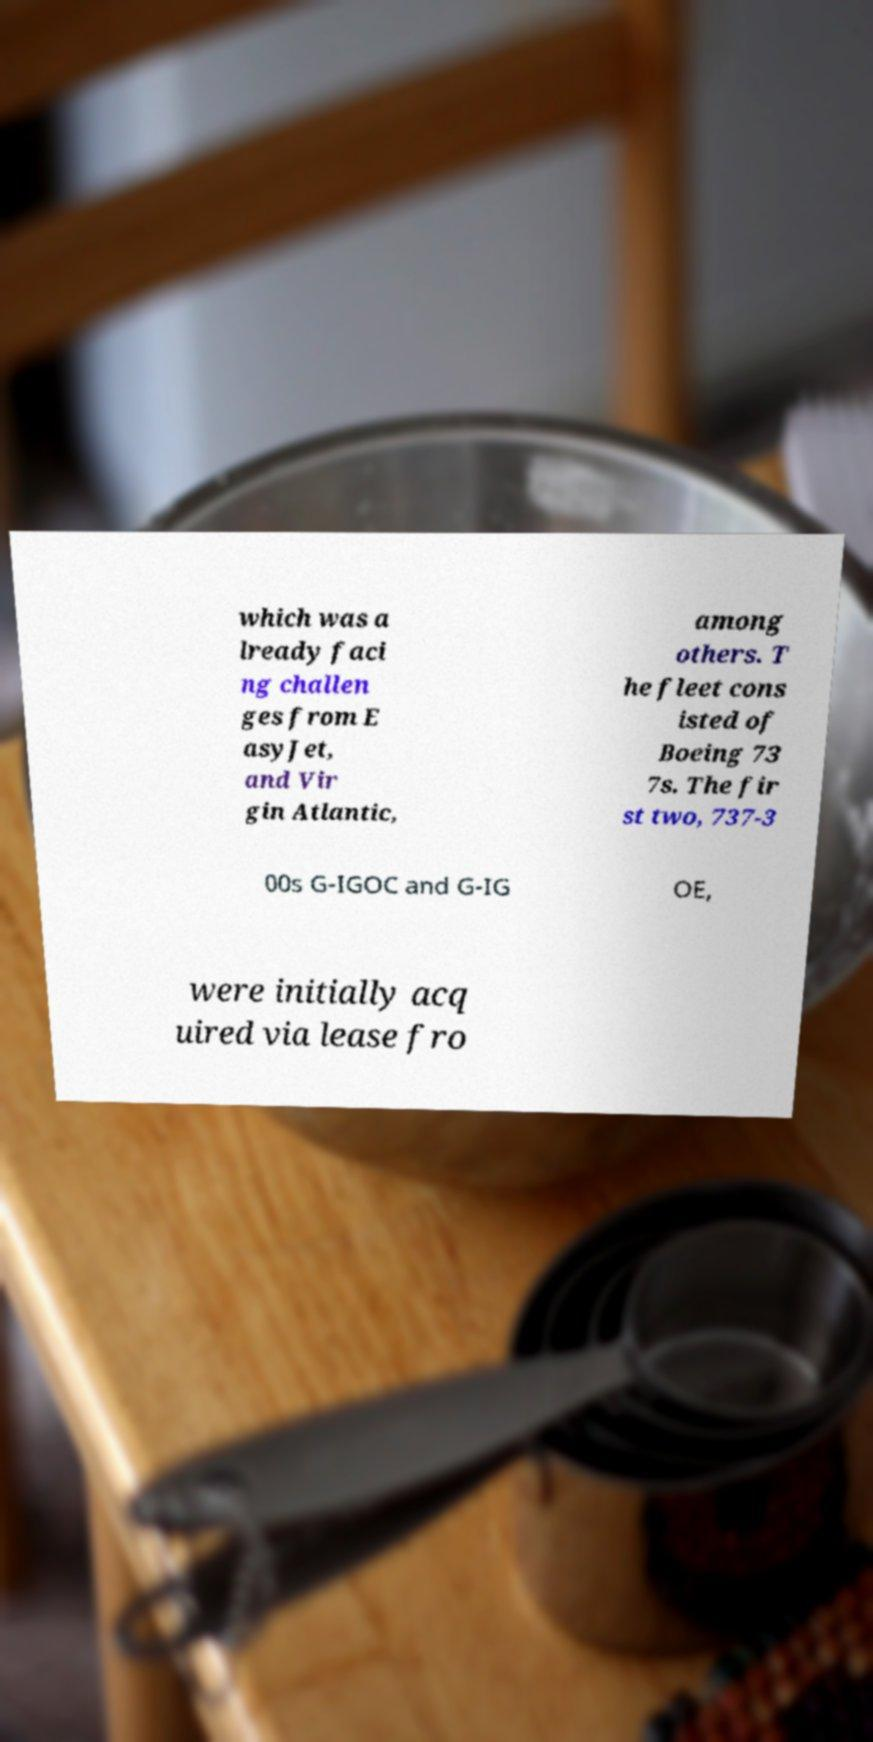What messages or text are displayed in this image? I need them in a readable, typed format. which was a lready faci ng challen ges from E asyJet, and Vir gin Atlantic, among others. T he fleet cons isted of Boeing 73 7s. The fir st two, 737-3 00s G-IGOC and G-IG OE, were initially acq uired via lease fro 